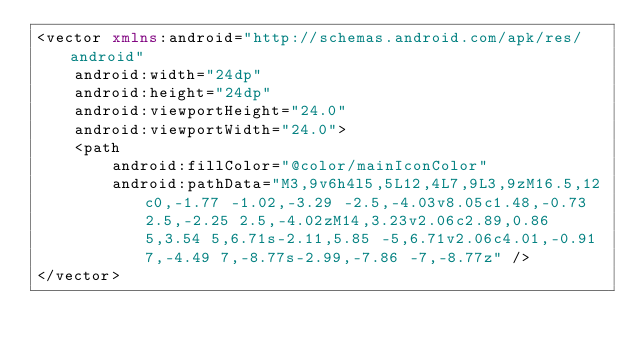<code> <loc_0><loc_0><loc_500><loc_500><_XML_><vector xmlns:android="http://schemas.android.com/apk/res/android"
    android:width="24dp"
    android:height="24dp"
    android:viewportHeight="24.0"
    android:viewportWidth="24.0">
    <path
        android:fillColor="@color/mainIconColor"
        android:pathData="M3,9v6h4l5,5L12,4L7,9L3,9zM16.5,12c0,-1.77 -1.02,-3.29 -2.5,-4.03v8.05c1.48,-0.73 2.5,-2.25 2.5,-4.02zM14,3.23v2.06c2.89,0.86 5,3.54 5,6.71s-2.11,5.85 -5,6.71v2.06c4.01,-0.91 7,-4.49 7,-8.77s-2.99,-7.86 -7,-8.77z" />
</vector>
</code> 